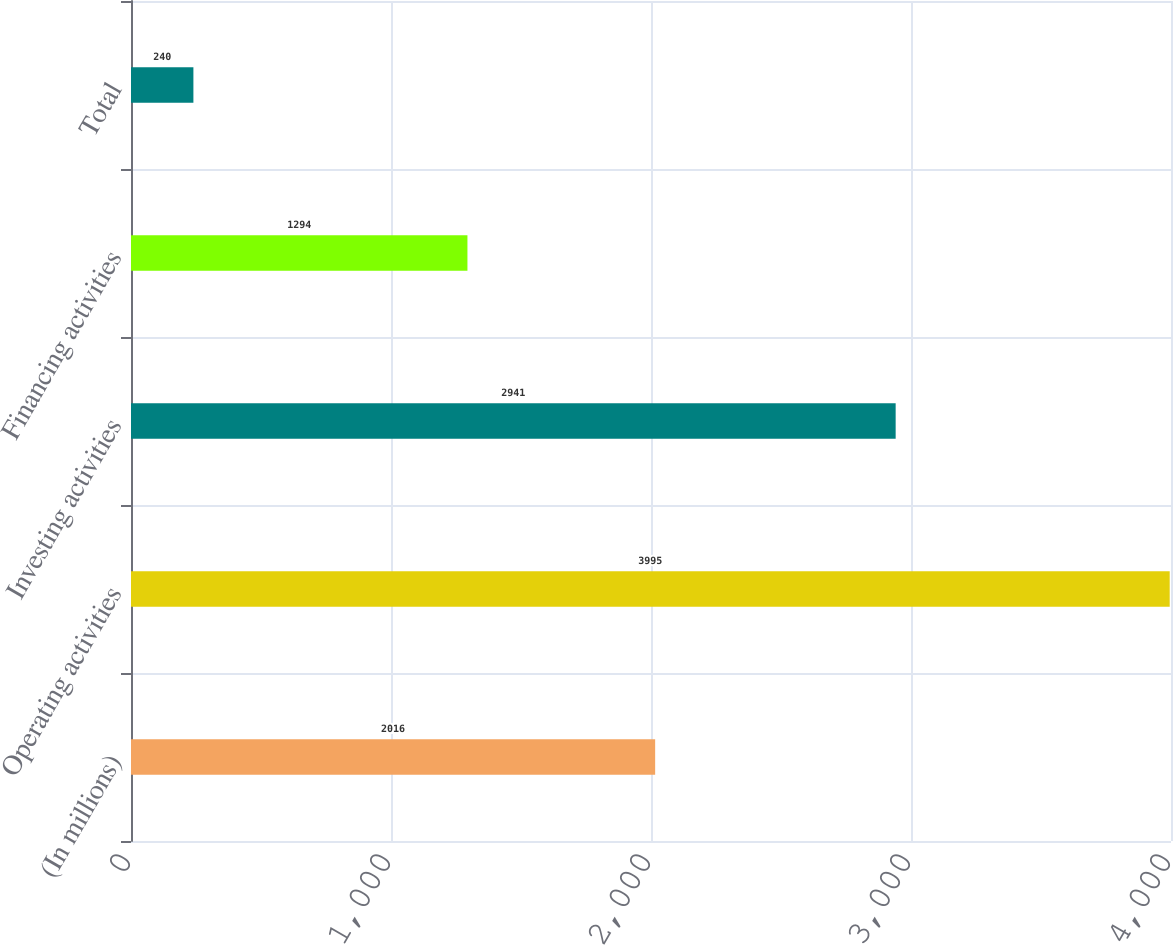Convert chart. <chart><loc_0><loc_0><loc_500><loc_500><bar_chart><fcel>(In millions)<fcel>Operating activities<fcel>Investing activities<fcel>Financing activities<fcel>Total<nl><fcel>2016<fcel>3995<fcel>2941<fcel>1294<fcel>240<nl></chart> 